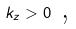<formula> <loc_0><loc_0><loc_500><loc_500>k _ { z } > 0 \text { ,}</formula> 